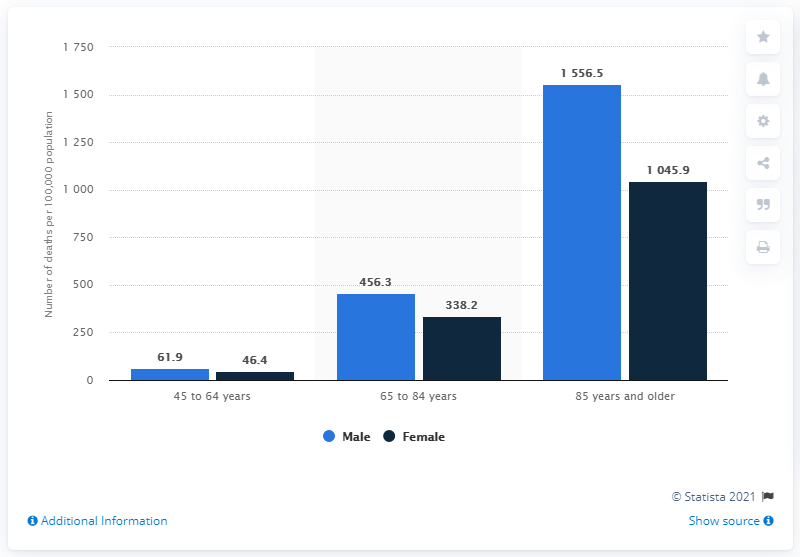Give some essential details in this illustration. In 2014, the death rate from chronic obstructive pulmonary disease (COPD) among males was 61.9 deaths per 100,000 males. 